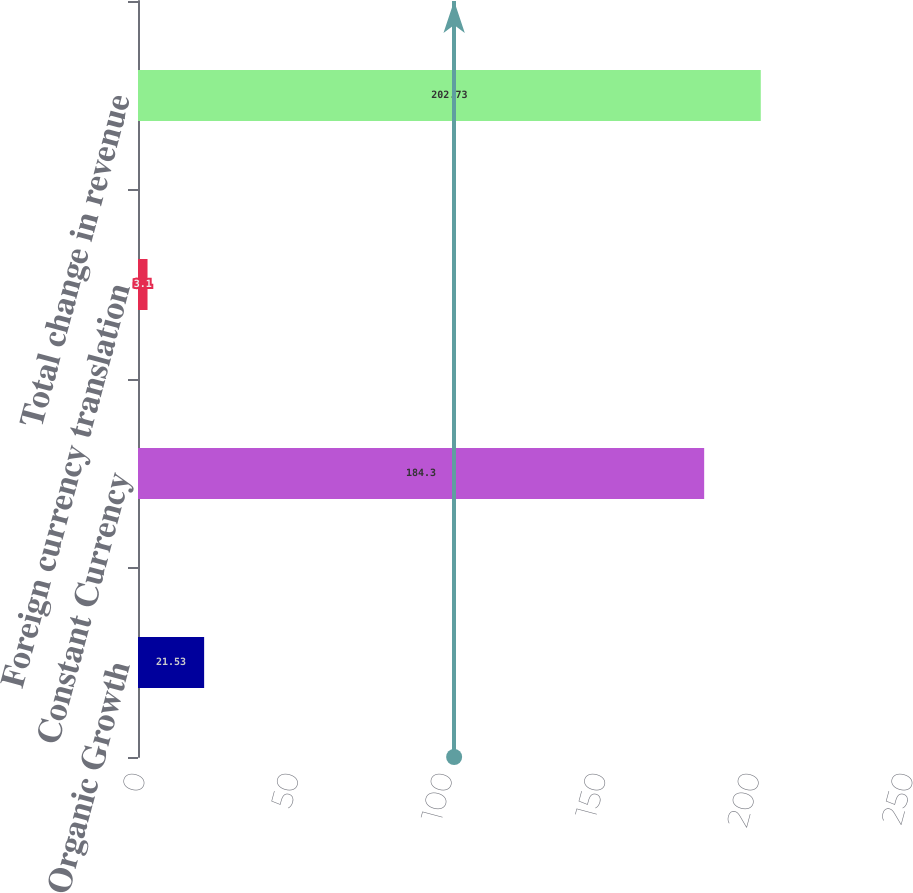Convert chart to OTSL. <chart><loc_0><loc_0><loc_500><loc_500><bar_chart><fcel>Organic Growth<fcel>Constant Currency<fcel>Foreign currency translation<fcel>Total change in revenue<nl><fcel>21.53<fcel>184.3<fcel>3.1<fcel>202.73<nl></chart> 